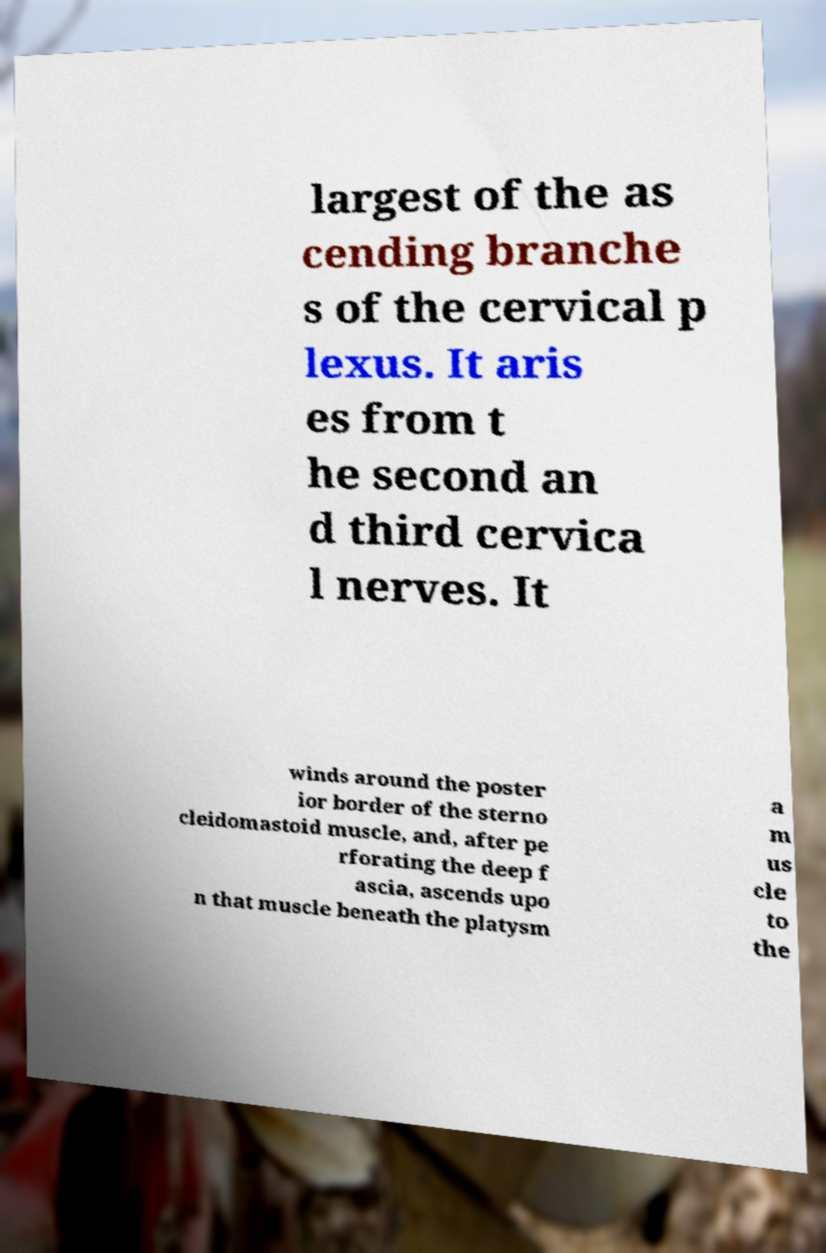Could you extract and type out the text from this image? largest of the as cending branche s of the cervical p lexus. It aris es from t he second an d third cervica l nerves. It winds around the poster ior border of the sterno cleidomastoid muscle, and, after pe rforating the deep f ascia, ascends upo n that muscle beneath the platysm a m us cle to the 